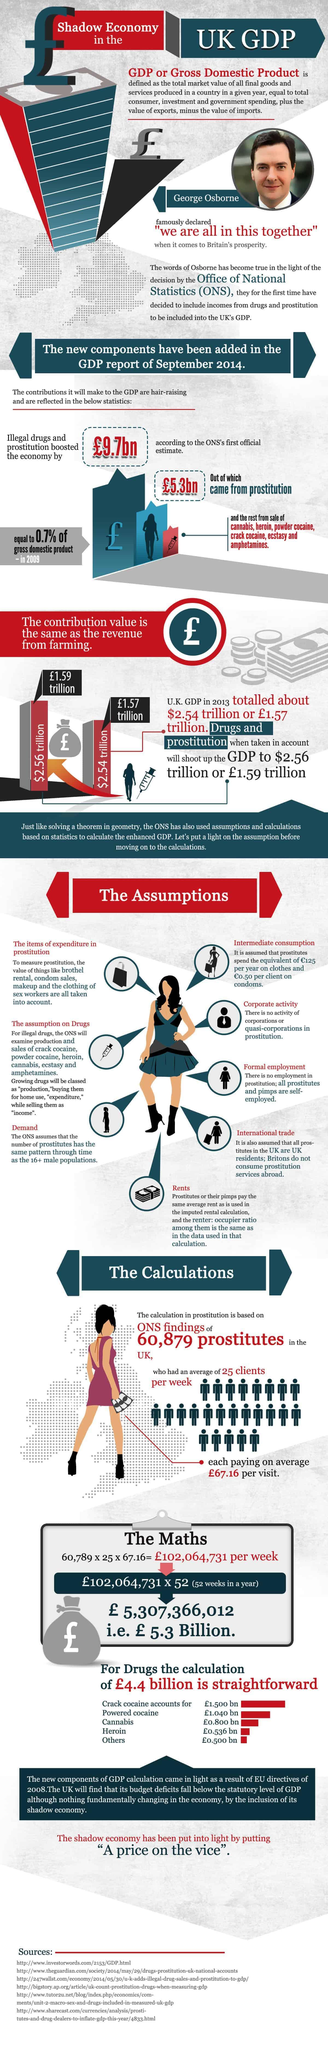Highlight a few significant elements in this photo. Six sources are listed at the bottom. 